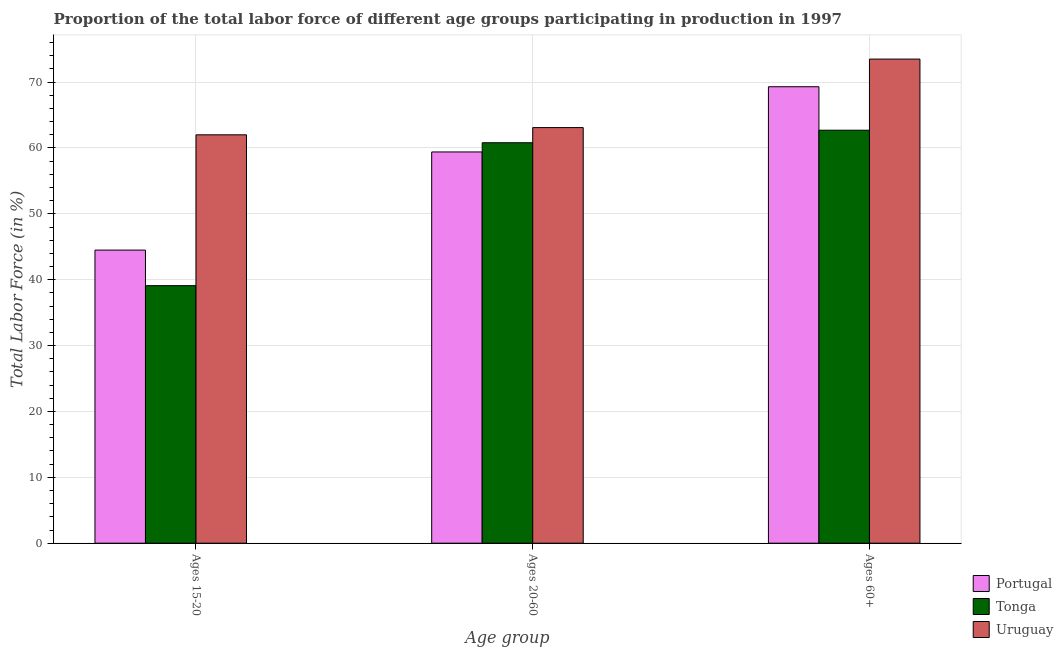How many different coloured bars are there?
Offer a very short reply. 3. Are the number of bars per tick equal to the number of legend labels?
Offer a very short reply. Yes. How many bars are there on the 1st tick from the left?
Provide a succinct answer. 3. What is the label of the 2nd group of bars from the left?
Your response must be concise. Ages 20-60. What is the percentage of labor force within the age group 20-60 in Uruguay?
Make the answer very short. 63.1. Across all countries, what is the maximum percentage of labor force within the age group 15-20?
Offer a terse response. 62. Across all countries, what is the minimum percentage of labor force above age 60?
Offer a terse response. 62.7. In which country was the percentage of labor force within the age group 15-20 maximum?
Offer a very short reply. Uruguay. In which country was the percentage of labor force above age 60 minimum?
Ensure brevity in your answer.  Tonga. What is the total percentage of labor force within the age group 15-20 in the graph?
Offer a terse response. 145.6. What is the difference between the percentage of labor force within the age group 15-20 in Portugal and that in Uruguay?
Give a very brief answer. -17.5. What is the difference between the percentage of labor force above age 60 in Portugal and the percentage of labor force within the age group 15-20 in Tonga?
Give a very brief answer. 30.2. What is the average percentage of labor force above age 60 per country?
Your answer should be compact. 68.5. What is the difference between the percentage of labor force within the age group 15-20 and percentage of labor force within the age group 20-60 in Tonga?
Your response must be concise. -21.7. What is the ratio of the percentage of labor force above age 60 in Tonga to that in Uruguay?
Provide a succinct answer. 0.85. Is the percentage of labor force above age 60 in Portugal less than that in Tonga?
Your response must be concise. No. Is the difference between the percentage of labor force within the age group 15-20 in Tonga and Uruguay greater than the difference between the percentage of labor force above age 60 in Tonga and Uruguay?
Offer a very short reply. No. What is the difference between the highest and the second highest percentage of labor force within the age group 15-20?
Your answer should be compact. 17.5. What is the difference between the highest and the lowest percentage of labor force within the age group 15-20?
Keep it short and to the point. 22.9. In how many countries, is the percentage of labor force above age 60 greater than the average percentage of labor force above age 60 taken over all countries?
Offer a very short reply. 2. Is the sum of the percentage of labor force above age 60 in Tonga and Uruguay greater than the maximum percentage of labor force within the age group 20-60 across all countries?
Ensure brevity in your answer.  Yes. What does the 3rd bar from the left in Ages 15-20 represents?
Provide a short and direct response. Uruguay. What does the 2nd bar from the right in Ages 20-60 represents?
Give a very brief answer. Tonga. Does the graph contain grids?
Your answer should be compact. Yes. Where does the legend appear in the graph?
Keep it short and to the point. Bottom right. What is the title of the graph?
Offer a terse response. Proportion of the total labor force of different age groups participating in production in 1997. Does "Jamaica" appear as one of the legend labels in the graph?
Provide a succinct answer. No. What is the label or title of the X-axis?
Give a very brief answer. Age group. What is the label or title of the Y-axis?
Provide a short and direct response. Total Labor Force (in %). What is the Total Labor Force (in %) of Portugal in Ages 15-20?
Your answer should be compact. 44.5. What is the Total Labor Force (in %) of Tonga in Ages 15-20?
Give a very brief answer. 39.1. What is the Total Labor Force (in %) in Uruguay in Ages 15-20?
Give a very brief answer. 62. What is the Total Labor Force (in %) in Portugal in Ages 20-60?
Give a very brief answer. 59.4. What is the Total Labor Force (in %) in Tonga in Ages 20-60?
Make the answer very short. 60.8. What is the Total Labor Force (in %) of Uruguay in Ages 20-60?
Offer a very short reply. 63.1. What is the Total Labor Force (in %) of Portugal in Ages 60+?
Your answer should be very brief. 69.3. What is the Total Labor Force (in %) in Tonga in Ages 60+?
Your answer should be compact. 62.7. What is the Total Labor Force (in %) in Uruguay in Ages 60+?
Keep it short and to the point. 73.5. Across all Age group, what is the maximum Total Labor Force (in %) in Portugal?
Provide a short and direct response. 69.3. Across all Age group, what is the maximum Total Labor Force (in %) in Tonga?
Your response must be concise. 62.7. Across all Age group, what is the maximum Total Labor Force (in %) in Uruguay?
Your answer should be very brief. 73.5. Across all Age group, what is the minimum Total Labor Force (in %) in Portugal?
Offer a terse response. 44.5. Across all Age group, what is the minimum Total Labor Force (in %) in Tonga?
Offer a terse response. 39.1. Across all Age group, what is the minimum Total Labor Force (in %) of Uruguay?
Ensure brevity in your answer.  62. What is the total Total Labor Force (in %) in Portugal in the graph?
Your answer should be compact. 173.2. What is the total Total Labor Force (in %) in Tonga in the graph?
Your answer should be compact. 162.6. What is the total Total Labor Force (in %) of Uruguay in the graph?
Make the answer very short. 198.6. What is the difference between the Total Labor Force (in %) of Portugal in Ages 15-20 and that in Ages 20-60?
Provide a short and direct response. -14.9. What is the difference between the Total Labor Force (in %) in Tonga in Ages 15-20 and that in Ages 20-60?
Keep it short and to the point. -21.7. What is the difference between the Total Labor Force (in %) of Uruguay in Ages 15-20 and that in Ages 20-60?
Your response must be concise. -1.1. What is the difference between the Total Labor Force (in %) in Portugal in Ages 15-20 and that in Ages 60+?
Ensure brevity in your answer.  -24.8. What is the difference between the Total Labor Force (in %) of Tonga in Ages 15-20 and that in Ages 60+?
Make the answer very short. -23.6. What is the difference between the Total Labor Force (in %) in Uruguay in Ages 20-60 and that in Ages 60+?
Ensure brevity in your answer.  -10.4. What is the difference between the Total Labor Force (in %) in Portugal in Ages 15-20 and the Total Labor Force (in %) in Tonga in Ages 20-60?
Provide a succinct answer. -16.3. What is the difference between the Total Labor Force (in %) in Portugal in Ages 15-20 and the Total Labor Force (in %) in Uruguay in Ages 20-60?
Your answer should be very brief. -18.6. What is the difference between the Total Labor Force (in %) in Tonga in Ages 15-20 and the Total Labor Force (in %) in Uruguay in Ages 20-60?
Give a very brief answer. -24. What is the difference between the Total Labor Force (in %) in Portugal in Ages 15-20 and the Total Labor Force (in %) in Tonga in Ages 60+?
Provide a succinct answer. -18.2. What is the difference between the Total Labor Force (in %) of Portugal in Ages 15-20 and the Total Labor Force (in %) of Uruguay in Ages 60+?
Provide a short and direct response. -29. What is the difference between the Total Labor Force (in %) in Tonga in Ages 15-20 and the Total Labor Force (in %) in Uruguay in Ages 60+?
Offer a very short reply. -34.4. What is the difference between the Total Labor Force (in %) of Portugal in Ages 20-60 and the Total Labor Force (in %) of Uruguay in Ages 60+?
Give a very brief answer. -14.1. What is the average Total Labor Force (in %) of Portugal per Age group?
Provide a short and direct response. 57.73. What is the average Total Labor Force (in %) of Tonga per Age group?
Your answer should be compact. 54.2. What is the average Total Labor Force (in %) of Uruguay per Age group?
Ensure brevity in your answer.  66.2. What is the difference between the Total Labor Force (in %) in Portugal and Total Labor Force (in %) in Uruguay in Ages 15-20?
Offer a terse response. -17.5. What is the difference between the Total Labor Force (in %) in Tonga and Total Labor Force (in %) in Uruguay in Ages 15-20?
Provide a short and direct response. -22.9. What is the difference between the Total Labor Force (in %) in Portugal and Total Labor Force (in %) in Tonga in Ages 20-60?
Give a very brief answer. -1.4. What is the difference between the Total Labor Force (in %) in Portugal and Total Labor Force (in %) in Tonga in Ages 60+?
Ensure brevity in your answer.  6.6. What is the difference between the Total Labor Force (in %) in Tonga and Total Labor Force (in %) in Uruguay in Ages 60+?
Your answer should be very brief. -10.8. What is the ratio of the Total Labor Force (in %) in Portugal in Ages 15-20 to that in Ages 20-60?
Your answer should be very brief. 0.75. What is the ratio of the Total Labor Force (in %) in Tonga in Ages 15-20 to that in Ages 20-60?
Give a very brief answer. 0.64. What is the ratio of the Total Labor Force (in %) in Uruguay in Ages 15-20 to that in Ages 20-60?
Your answer should be compact. 0.98. What is the ratio of the Total Labor Force (in %) of Portugal in Ages 15-20 to that in Ages 60+?
Keep it short and to the point. 0.64. What is the ratio of the Total Labor Force (in %) of Tonga in Ages 15-20 to that in Ages 60+?
Your answer should be very brief. 0.62. What is the ratio of the Total Labor Force (in %) in Uruguay in Ages 15-20 to that in Ages 60+?
Your answer should be compact. 0.84. What is the ratio of the Total Labor Force (in %) of Portugal in Ages 20-60 to that in Ages 60+?
Your answer should be compact. 0.86. What is the ratio of the Total Labor Force (in %) in Tonga in Ages 20-60 to that in Ages 60+?
Give a very brief answer. 0.97. What is the ratio of the Total Labor Force (in %) in Uruguay in Ages 20-60 to that in Ages 60+?
Provide a succinct answer. 0.86. What is the difference between the highest and the second highest Total Labor Force (in %) in Portugal?
Your response must be concise. 9.9. What is the difference between the highest and the lowest Total Labor Force (in %) in Portugal?
Ensure brevity in your answer.  24.8. What is the difference between the highest and the lowest Total Labor Force (in %) in Tonga?
Offer a very short reply. 23.6. 